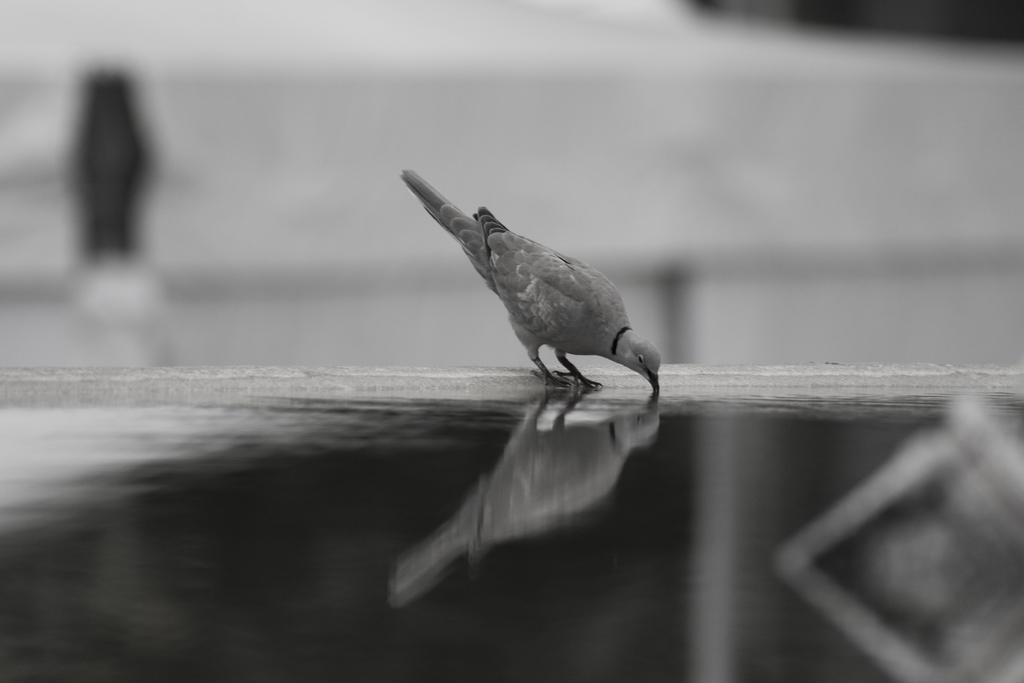What type of image is depicted in the picture? The image contains a black and white picture of a bird. What can be seen in the foreground of the image? There is water visible in the foreground of the image. What riddle is the bird trying to solve in the image? There is no riddle present in the image; it is a static picture of a bird. 